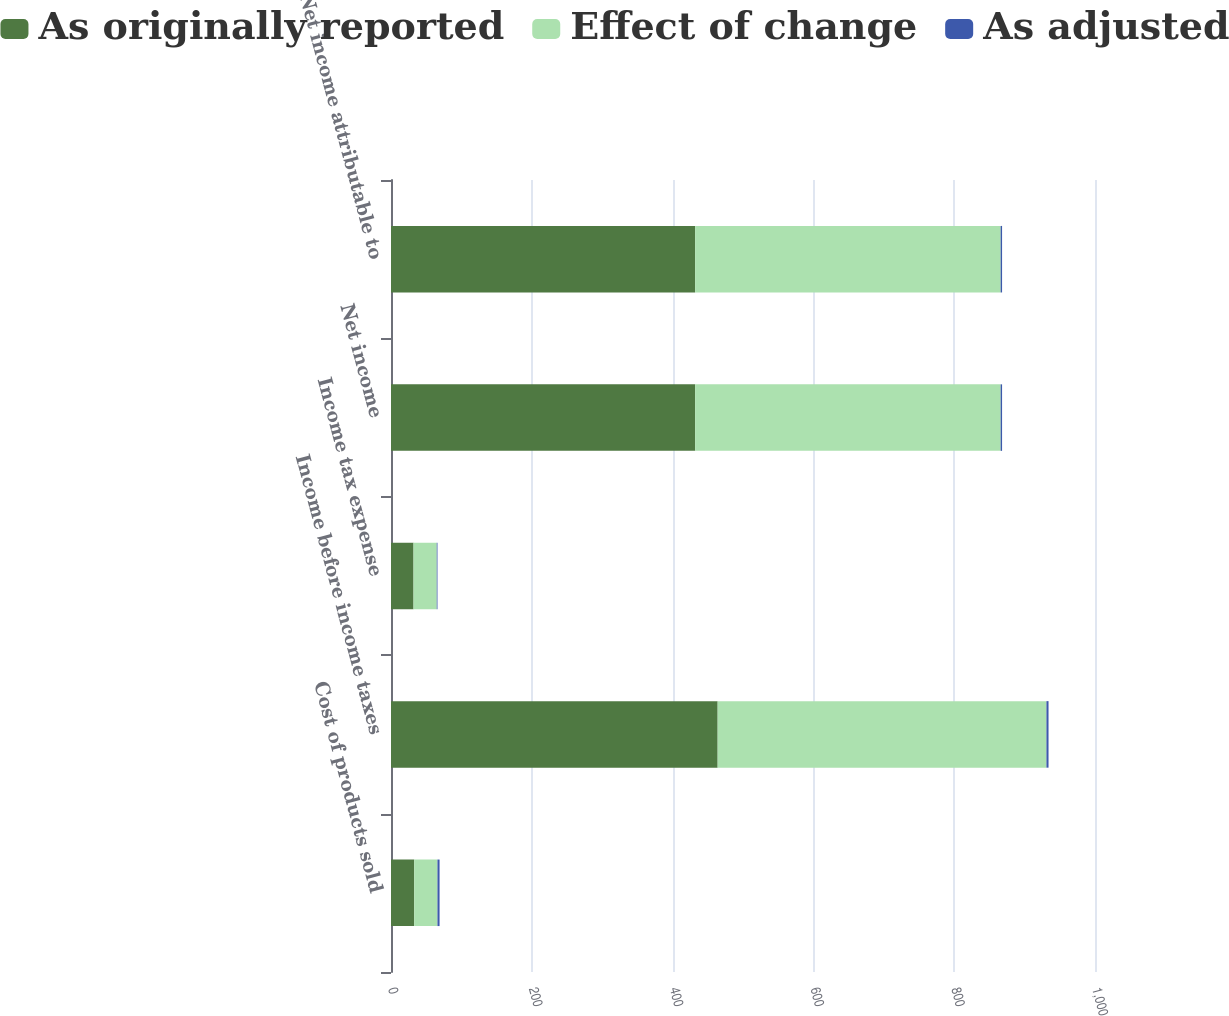<chart> <loc_0><loc_0><loc_500><loc_500><stacked_bar_chart><ecel><fcel>Cost of products sold<fcel>Income before income taxes<fcel>Income tax expense<fcel>Net income<fcel>Net income attributable to<nl><fcel>As originally reported<fcel>33<fcel>464<fcel>32<fcel>432<fcel>432<nl><fcel>Effect of change<fcel>33<fcel>467<fcel>33<fcel>434<fcel>434<nl><fcel>As adjusted<fcel>3<fcel>3<fcel>1<fcel>2<fcel>2<nl></chart> 